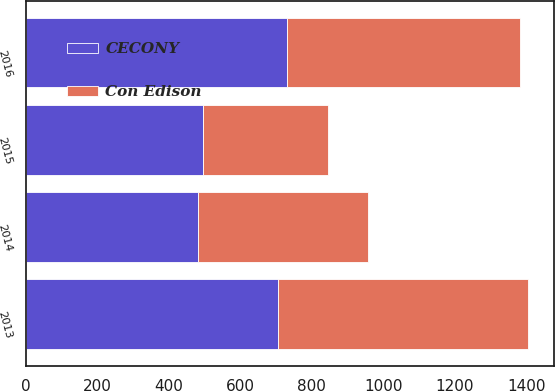<chart> <loc_0><loc_0><loc_500><loc_500><stacked_bar_chart><ecel><fcel>2013<fcel>2014<fcel>2015<fcel>2016<nl><fcel>CECONY<fcel>706<fcel>481<fcel>495<fcel>731<nl><fcel>Con Edison<fcel>700<fcel>475<fcel>350<fcel>650<nl></chart> 